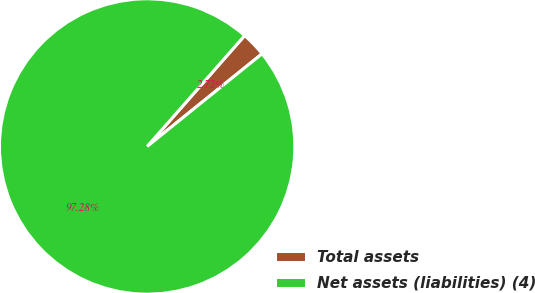<chart> <loc_0><loc_0><loc_500><loc_500><pie_chart><fcel>Total assets<fcel>Net assets (liabilities) (4)<nl><fcel>2.72%<fcel>97.28%<nl></chart> 